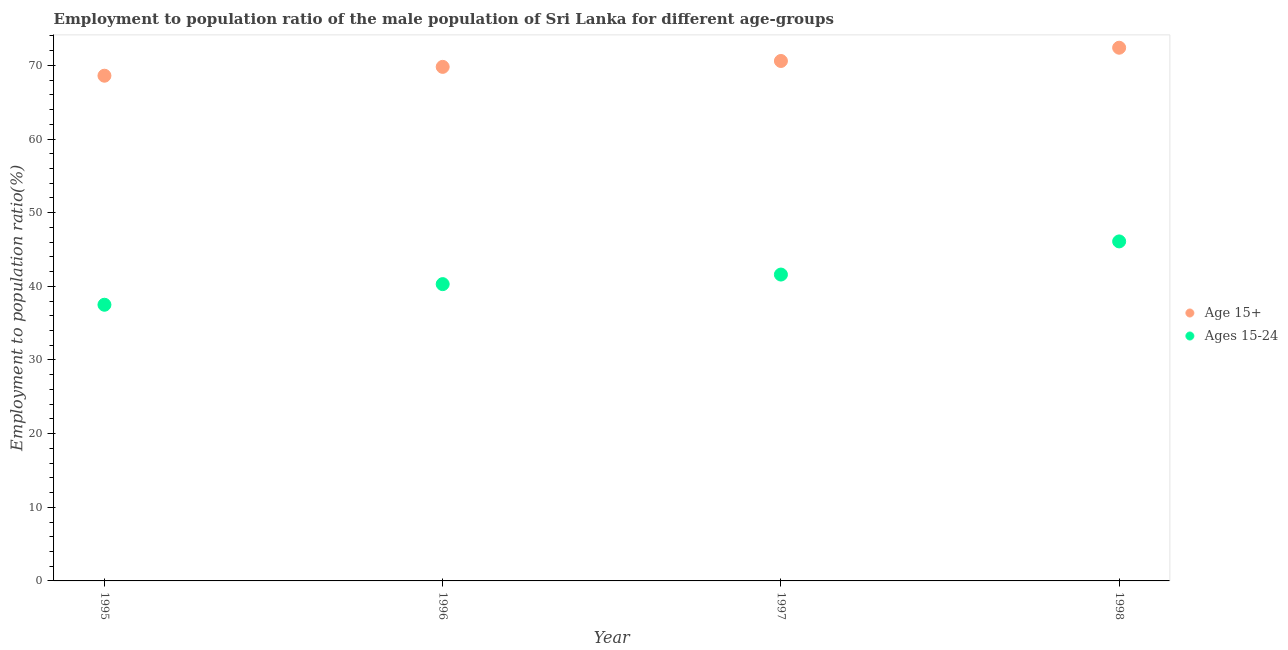Is the number of dotlines equal to the number of legend labels?
Your answer should be compact. Yes. What is the employment to population ratio(age 15-24) in 1997?
Keep it short and to the point. 41.6. Across all years, what is the maximum employment to population ratio(age 15+)?
Provide a short and direct response. 72.4. Across all years, what is the minimum employment to population ratio(age 15-24)?
Ensure brevity in your answer.  37.5. What is the total employment to population ratio(age 15-24) in the graph?
Ensure brevity in your answer.  165.5. What is the difference between the employment to population ratio(age 15+) in 1995 and that in 1998?
Provide a succinct answer. -3.8. What is the difference between the employment to population ratio(age 15+) in 1998 and the employment to population ratio(age 15-24) in 1995?
Your answer should be very brief. 34.9. What is the average employment to population ratio(age 15+) per year?
Keep it short and to the point. 70.35. In the year 1998, what is the difference between the employment to population ratio(age 15+) and employment to population ratio(age 15-24)?
Your answer should be very brief. 26.3. What is the ratio of the employment to population ratio(age 15-24) in 1996 to that in 1998?
Offer a very short reply. 0.87. What is the difference between the highest and the second highest employment to population ratio(age 15+)?
Your answer should be very brief. 1.8. What is the difference between the highest and the lowest employment to population ratio(age 15-24)?
Provide a short and direct response. 8.6. Is the sum of the employment to population ratio(age 15-24) in 1997 and 1998 greater than the maximum employment to population ratio(age 15+) across all years?
Your answer should be compact. Yes. Is the employment to population ratio(age 15-24) strictly less than the employment to population ratio(age 15+) over the years?
Offer a terse response. Yes. How many dotlines are there?
Make the answer very short. 2. How many years are there in the graph?
Your answer should be compact. 4. What is the difference between two consecutive major ticks on the Y-axis?
Provide a succinct answer. 10. Does the graph contain any zero values?
Provide a succinct answer. No. Where does the legend appear in the graph?
Ensure brevity in your answer.  Center right. How many legend labels are there?
Make the answer very short. 2. What is the title of the graph?
Your response must be concise. Employment to population ratio of the male population of Sri Lanka for different age-groups. Does "International Visitors" appear as one of the legend labels in the graph?
Your response must be concise. No. What is the Employment to population ratio(%) of Age 15+ in 1995?
Give a very brief answer. 68.6. What is the Employment to population ratio(%) of Ages 15-24 in 1995?
Your response must be concise. 37.5. What is the Employment to population ratio(%) in Age 15+ in 1996?
Offer a very short reply. 69.8. What is the Employment to population ratio(%) in Ages 15-24 in 1996?
Give a very brief answer. 40.3. What is the Employment to population ratio(%) of Age 15+ in 1997?
Ensure brevity in your answer.  70.6. What is the Employment to population ratio(%) of Ages 15-24 in 1997?
Offer a terse response. 41.6. What is the Employment to population ratio(%) in Age 15+ in 1998?
Make the answer very short. 72.4. What is the Employment to population ratio(%) in Ages 15-24 in 1998?
Your answer should be very brief. 46.1. Across all years, what is the maximum Employment to population ratio(%) of Age 15+?
Offer a very short reply. 72.4. Across all years, what is the maximum Employment to population ratio(%) in Ages 15-24?
Keep it short and to the point. 46.1. Across all years, what is the minimum Employment to population ratio(%) in Age 15+?
Offer a terse response. 68.6. Across all years, what is the minimum Employment to population ratio(%) of Ages 15-24?
Offer a terse response. 37.5. What is the total Employment to population ratio(%) in Age 15+ in the graph?
Provide a succinct answer. 281.4. What is the total Employment to population ratio(%) of Ages 15-24 in the graph?
Offer a terse response. 165.5. What is the difference between the Employment to population ratio(%) of Age 15+ in 1995 and that in 1996?
Make the answer very short. -1.2. What is the difference between the Employment to population ratio(%) of Ages 15-24 in 1995 and that in 1996?
Provide a short and direct response. -2.8. What is the difference between the Employment to population ratio(%) in Age 15+ in 1995 and that in 1997?
Offer a terse response. -2. What is the difference between the Employment to population ratio(%) in Age 15+ in 1995 and that in 1998?
Make the answer very short. -3.8. What is the difference between the Employment to population ratio(%) of Ages 15-24 in 1995 and that in 1998?
Offer a very short reply. -8.6. What is the difference between the Employment to population ratio(%) in Ages 15-24 in 1996 and that in 1998?
Your response must be concise. -5.8. What is the difference between the Employment to population ratio(%) in Ages 15-24 in 1997 and that in 1998?
Your response must be concise. -4.5. What is the difference between the Employment to population ratio(%) in Age 15+ in 1995 and the Employment to population ratio(%) in Ages 15-24 in 1996?
Provide a succinct answer. 28.3. What is the difference between the Employment to population ratio(%) of Age 15+ in 1995 and the Employment to population ratio(%) of Ages 15-24 in 1997?
Provide a short and direct response. 27. What is the difference between the Employment to population ratio(%) of Age 15+ in 1996 and the Employment to population ratio(%) of Ages 15-24 in 1997?
Provide a short and direct response. 28.2. What is the difference between the Employment to population ratio(%) in Age 15+ in 1996 and the Employment to population ratio(%) in Ages 15-24 in 1998?
Offer a terse response. 23.7. What is the average Employment to population ratio(%) of Age 15+ per year?
Provide a succinct answer. 70.35. What is the average Employment to population ratio(%) in Ages 15-24 per year?
Your answer should be compact. 41.38. In the year 1995, what is the difference between the Employment to population ratio(%) of Age 15+ and Employment to population ratio(%) of Ages 15-24?
Give a very brief answer. 31.1. In the year 1996, what is the difference between the Employment to population ratio(%) of Age 15+ and Employment to population ratio(%) of Ages 15-24?
Offer a terse response. 29.5. In the year 1998, what is the difference between the Employment to population ratio(%) in Age 15+ and Employment to population ratio(%) in Ages 15-24?
Offer a very short reply. 26.3. What is the ratio of the Employment to population ratio(%) in Age 15+ in 1995 to that in 1996?
Ensure brevity in your answer.  0.98. What is the ratio of the Employment to population ratio(%) in Ages 15-24 in 1995 to that in 1996?
Your response must be concise. 0.93. What is the ratio of the Employment to population ratio(%) in Age 15+ in 1995 to that in 1997?
Give a very brief answer. 0.97. What is the ratio of the Employment to population ratio(%) in Ages 15-24 in 1995 to that in 1997?
Your response must be concise. 0.9. What is the ratio of the Employment to population ratio(%) of Age 15+ in 1995 to that in 1998?
Offer a terse response. 0.95. What is the ratio of the Employment to population ratio(%) in Ages 15-24 in 1995 to that in 1998?
Keep it short and to the point. 0.81. What is the ratio of the Employment to population ratio(%) in Age 15+ in 1996 to that in 1997?
Ensure brevity in your answer.  0.99. What is the ratio of the Employment to population ratio(%) of Ages 15-24 in 1996 to that in 1997?
Give a very brief answer. 0.97. What is the ratio of the Employment to population ratio(%) in Age 15+ in 1996 to that in 1998?
Your response must be concise. 0.96. What is the ratio of the Employment to population ratio(%) of Ages 15-24 in 1996 to that in 1998?
Keep it short and to the point. 0.87. What is the ratio of the Employment to population ratio(%) of Age 15+ in 1997 to that in 1998?
Your response must be concise. 0.98. What is the ratio of the Employment to population ratio(%) in Ages 15-24 in 1997 to that in 1998?
Offer a terse response. 0.9. What is the difference between the highest and the second highest Employment to population ratio(%) in Ages 15-24?
Offer a terse response. 4.5. What is the difference between the highest and the lowest Employment to population ratio(%) of Age 15+?
Provide a short and direct response. 3.8. What is the difference between the highest and the lowest Employment to population ratio(%) in Ages 15-24?
Give a very brief answer. 8.6. 